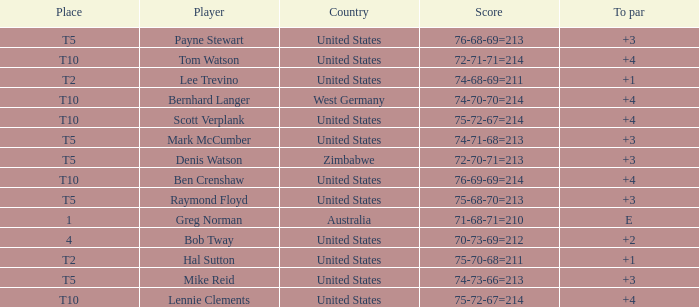Who is the player with a +3 to par and a 74-71-68=213 score? Mark McCumber. 